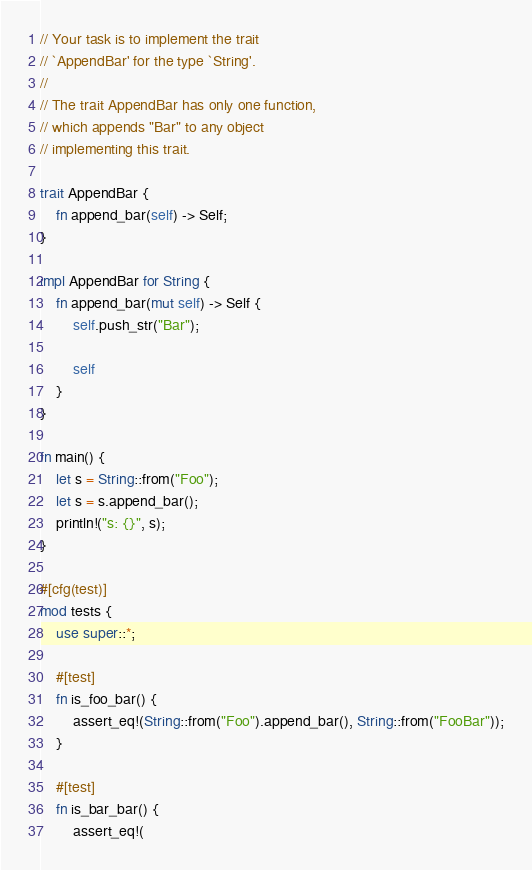<code> <loc_0><loc_0><loc_500><loc_500><_Rust_>// Your task is to implement the trait
// `AppendBar' for the type `String'.
//
// The trait AppendBar has only one function,
// which appends "Bar" to any object
// implementing this trait.

trait AppendBar {
    fn append_bar(self) -> Self;
}

impl AppendBar for String {
    fn append_bar(mut self) -> Self {
        self.push_str("Bar");

        self
    }
}

fn main() {
    let s = String::from("Foo");
    let s = s.append_bar();
    println!("s: {}", s);
}

#[cfg(test)]
mod tests {
    use super::*;

    #[test]
    fn is_foo_bar() {
        assert_eq!(String::from("Foo").append_bar(), String::from("FooBar"));
    }

    #[test]
    fn is_bar_bar() {
        assert_eq!(</code> 